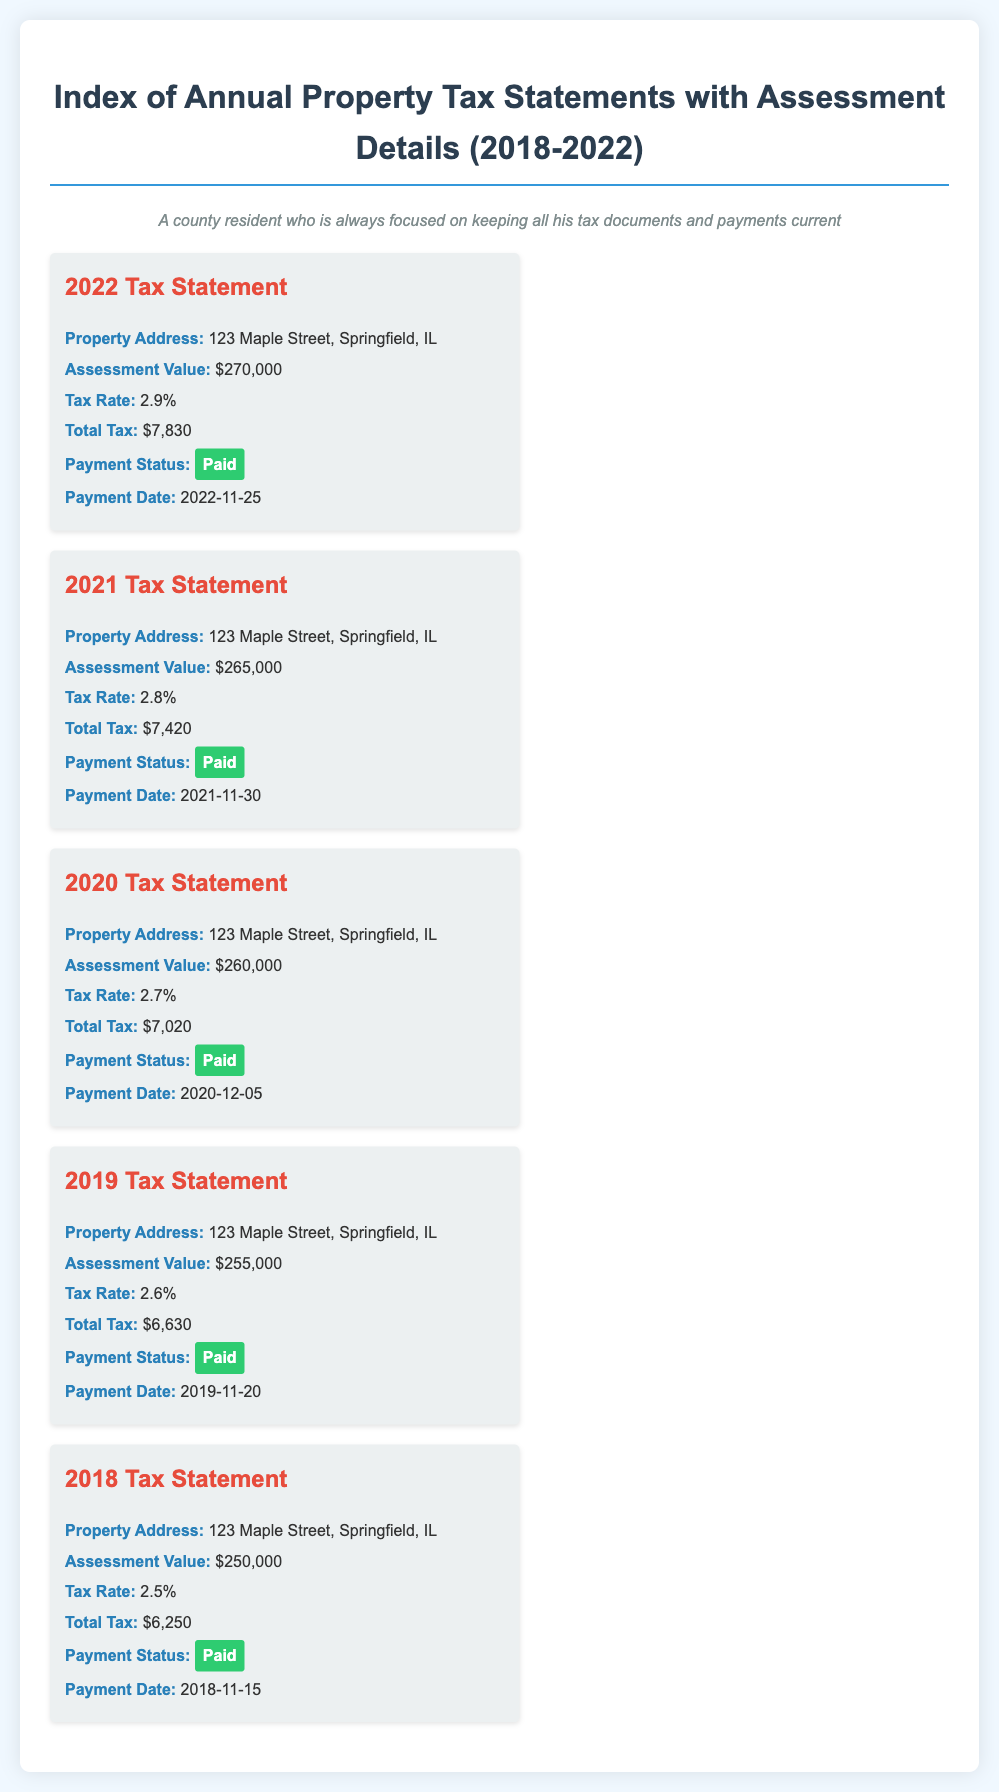what is the property address for the 2022 tax statement? The property address is specified in the tax statement for 2022, which is 123 Maple Street, Springfield, IL.
Answer: 123 Maple Street, Springfield, IL what was the total tax for the year 2021? The total tax for 2021 is mentioned in the tax statement, which is $7,420.
Answer: $7,420 what is the assessment value for the year 2019? The assessment value for 2019 is listed in the respective tax statement as $255,000.
Answer: $255,000 how much did the property tax rate increase from 2018 to 2022? To find the increase, compare the tax rates for 2018 (2.5%) and 2022 (2.9%), which is an increase of 0.4%.
Answer: 0.4% which year had the lowest total tax? By comparing total taxes from each year, the lowest is identified in 2018, which is $6,250.
Answer: 2018 